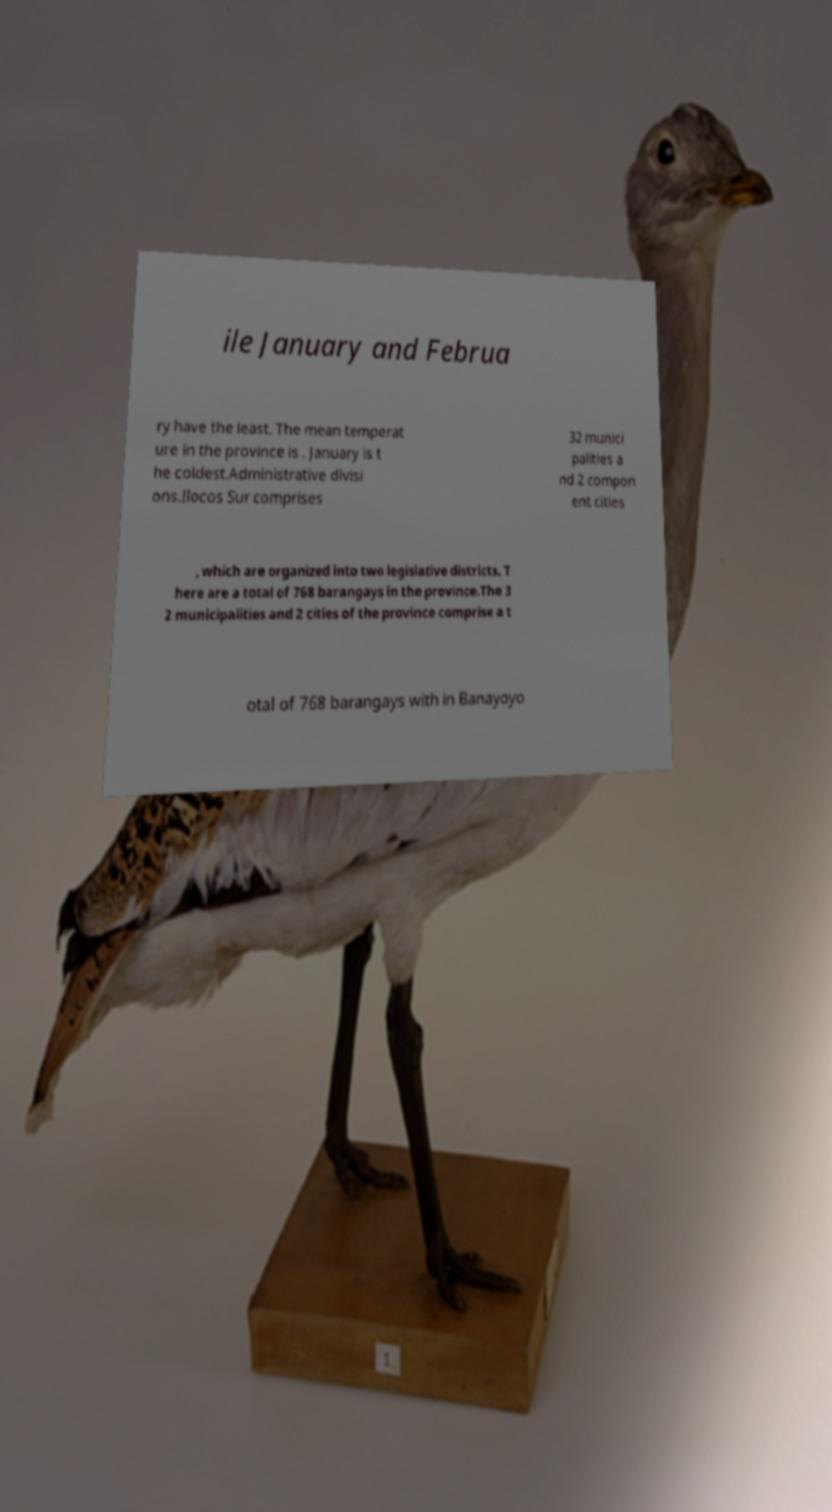Can you read and provide the text displayed in the image?This photo seems to have some interesting text. Can you extract and type it out for me? ile January and Februa ry have the least. The mean temperat ure in the province is . January is t he coldest.Administrative divisi ons.Ilocos Sur comprises 32 munici palities a nd 2 compon ent cities , which are organized into two legislative districts. T here are a total of 768 barangays in the province.The 3 2 municipalities and 2 cities of the province comprise a t otal of 768 barangays with in Banayoyo 